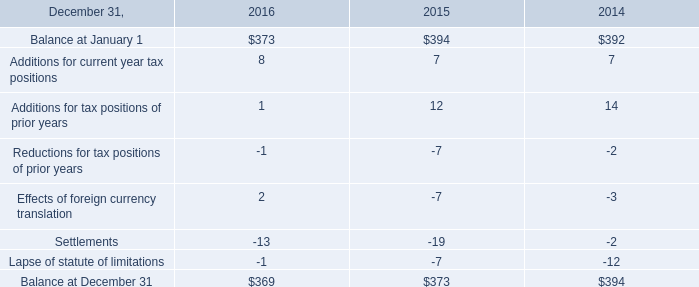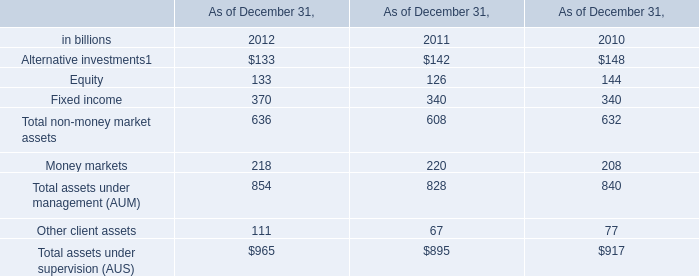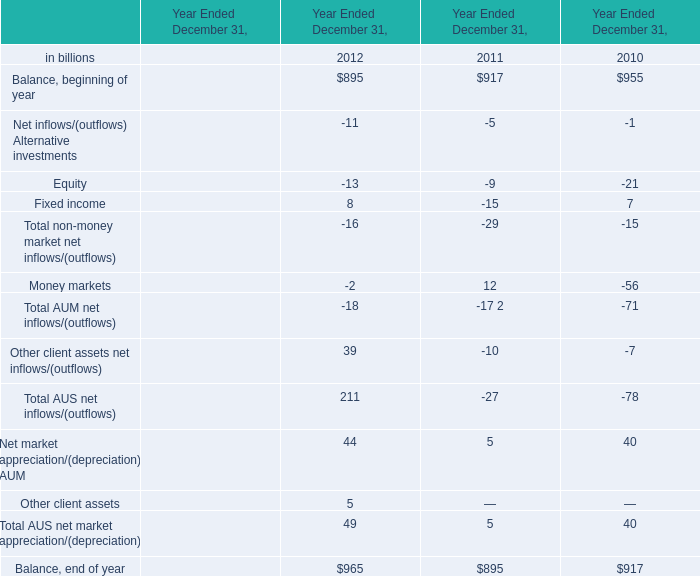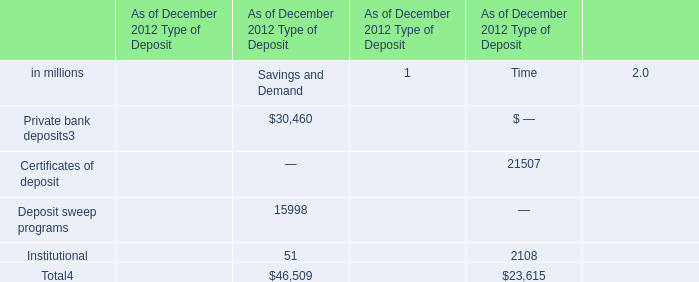Does the proportion of equity in total larger than that of fixed income in 2012? 
Computations: ((-9 / -29) - (-15 / -29))
Answer: -0.2069. 